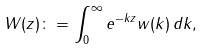Convert formula to latex. <formula><loc_0><loc_0><loc_500><loc_500>W ( z ) \colon = \int _ { 0 } ^ { \infty } e ^ { - k z } w ( k ) \, d k ,</formula> 